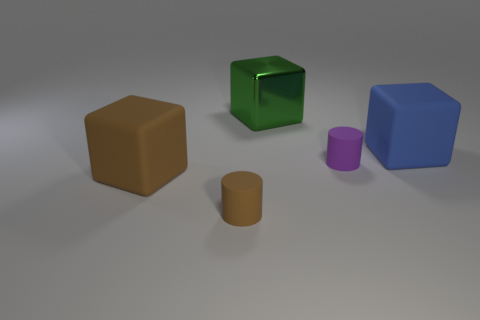Can you describe the shapes and colors of the objects presented in the image? Certainly! The image displays five objects with varying shapes and colors. On the left is a brown cube, followed by a shiny green cube with a reflective surface. Next is a purple cylinder standing upright, and a small brown cylinder in front. On the right, there is a blue cube with a matte finish. 